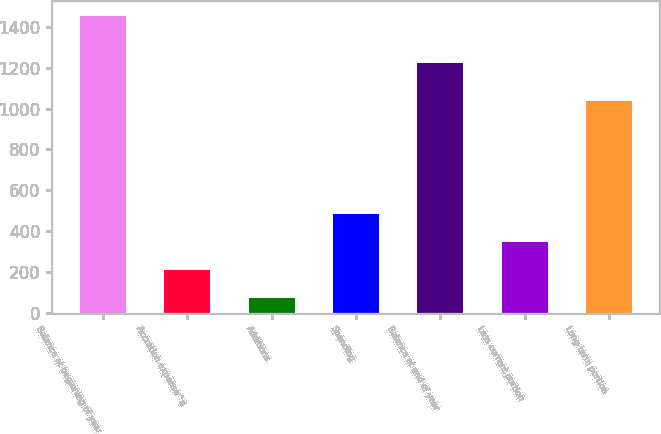Convert chart to OTSL. <chart><loc_0><loc_0><loc_500><loc_500><bar_chart><fcel>Balance at beginning of year<fcel>Accretion expense^a<fcel>Additions<fcel>Spending<fcel>Balance at end of year<fcel>Less current portion<fcel>Long-term portion<nl><fcel>1453<fcel>208.3<fcel>70<fcel>484.9<fcel>1222<fcel>346.6<fcel>1036<nl></chart> 